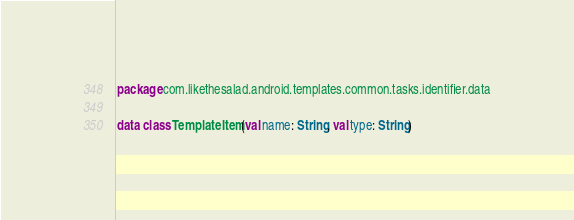Convert code to text. <code><loc_0><loc_0><loc_500><loc_500><_Kotlin_>package com.likethesalad.android.templates.common.tasks.identifier.data

data class TemplateItem(val name: String, val type: String)</code> 